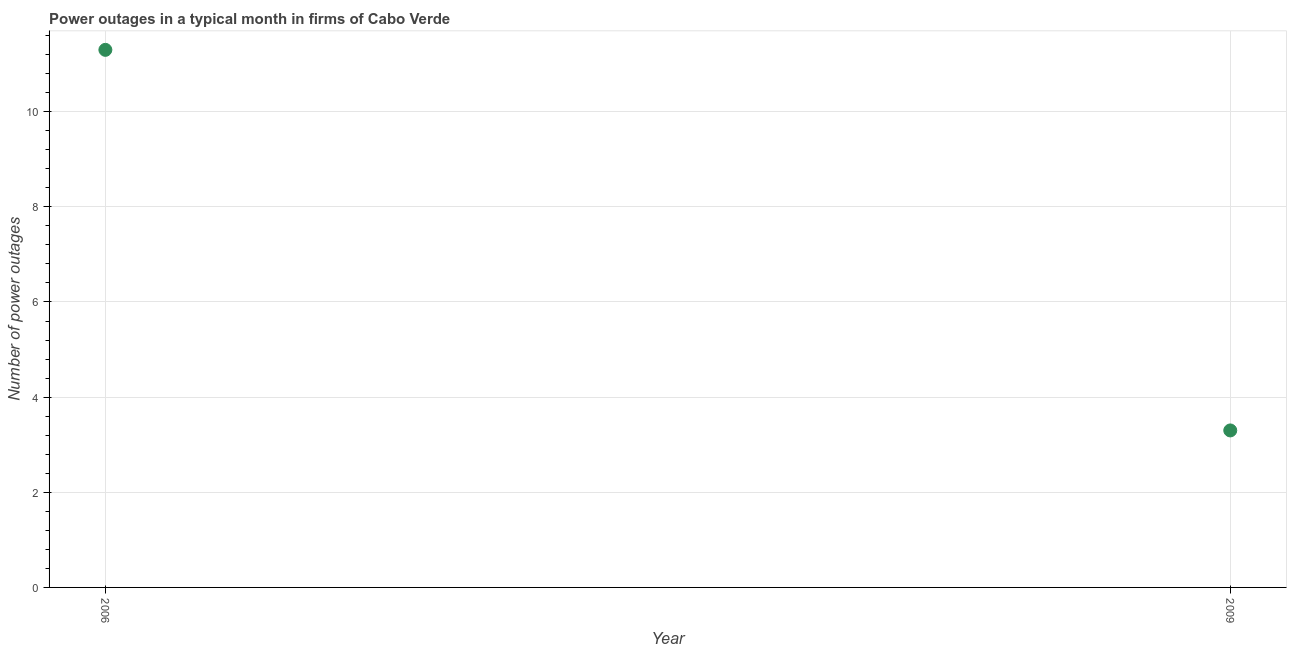What is the number of power outages in 2006?
Give a very brief answer. 11.3. In which year was the number of power outages maximum?
Keep it short and to the point. 2006. What is the sum of the number of power outages?
Provide a succinct answer. 14.6. What is the average number of power outages per year?
Give a very brief answer. 7.3. What is the median number of power outages?
Ensure brevity in your answer.  7.3. What is the ratio of the number of power outages in 2006 to that in 2009?
Give a very brief answer. 3.42. What is the difference between two consecutive major ticks on the Y-axis?
Ensure brevity in your answer.  2. Does the graph contain any zero values?
Your response must be concise. No. What is the title of the graph?
Offer a terse response. Power outages in a typical month in firms of Cabo Verde. What is the label or title of the Y-axis?
Offer a terse response. Number of power outages. What is the Number of power outages in 2009?
Provide a short and direct response. 3.3. What is the difference between the Number of power outages in 2006 and 2009?
Offer a very short reply. 8. What is the ratio of the Number of power outages in 2006 to that in 2009?
Provide a short and direct response. 3.42. 